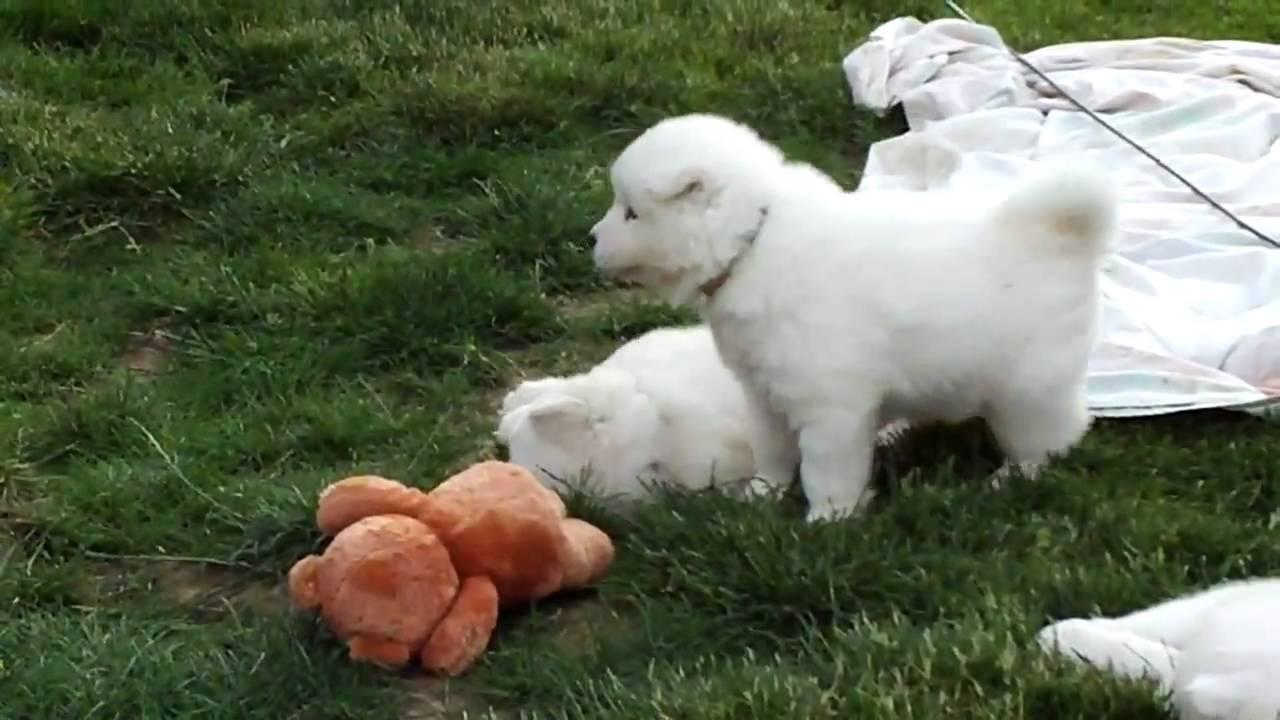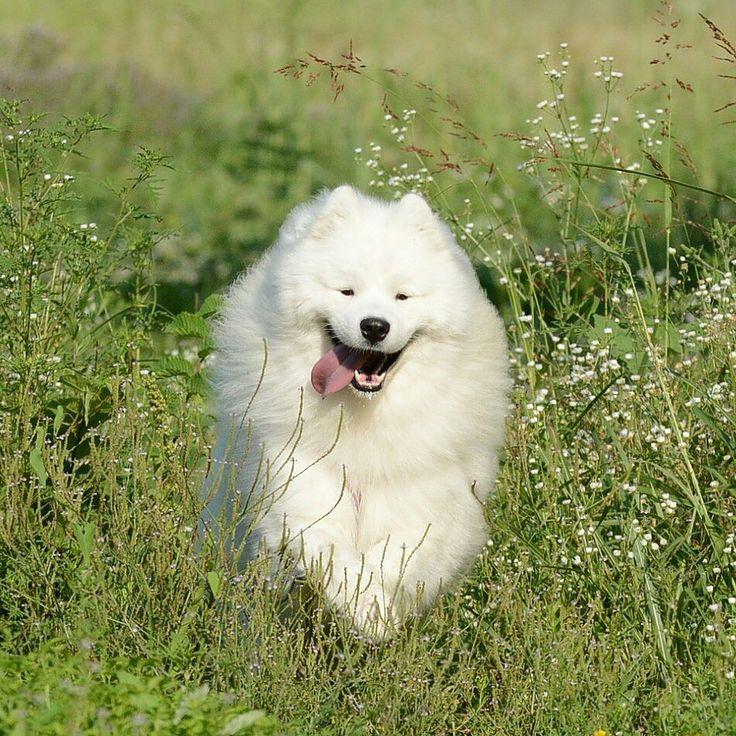The first image is the image on the left, the second image is the image on the right. Given the left and right images, does the statement "An image shows at least one dog running toward the camera." hold true? Answer yes or no. Yes. 